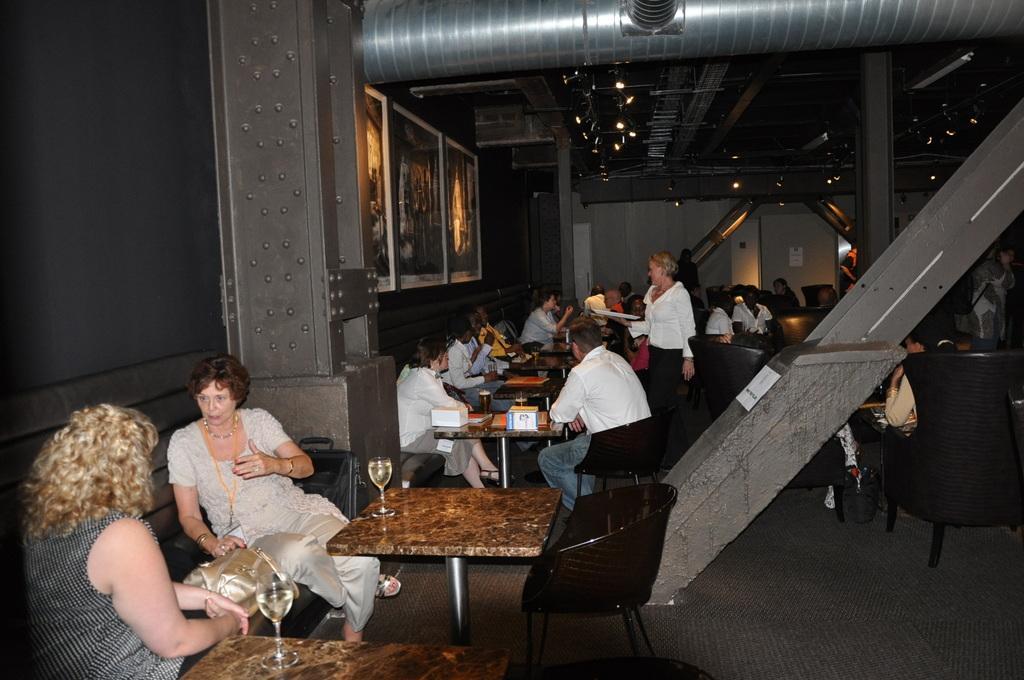Describe this image in one or two sentences. There are some people sitting in the sofa in front of the tables on which gases were present. In the background, there are some people sitting and eating on their tables. There are some photographs attached to the wall. In a background we can also a wall here. 